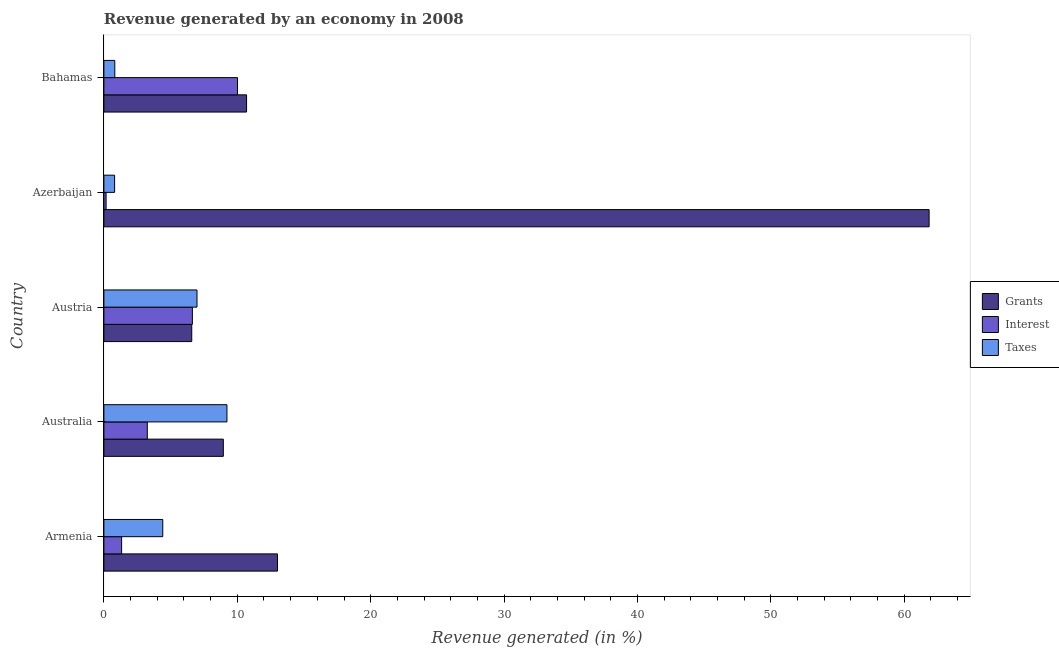How many groups of bars are there?
Ensure brevity in your answer.  5. Are the number of bars on each tick of the Y-axis equal?
Make the answer very short. Yes. How many bars are there on the 2nd tick from the top?
Make the answer very short. 3. In how many cases, is the number of bars for a given country not equal to the number of legend labels?
Make the answer very short. 0. What is the percentage of revenue generated by interest in Bahamas?
Offer a terse response. 10.02. Across all countries, what is the maximum percentage of revenue generated by grants?
Your answer should be very brief. 61.87. Across all countries, what is the minimum percentage of revenue generated by interest?
Ensure brevity in your answer.  0.17. In which country was the percentage of revenue generated by interest minimum?
Your response must be concise. Azerbaijan. What is the total percentage of revenue generated by grants in the graph?
Give a very brief answer. 101.12. What is the difference between the percentage of revenue generated by interest in Armenia and that in Azerbaijan?
Offer a very short reply. 1.17. What is the difference between the percentage of revenue generated by interest in Austria and the percentage of revenue generated by grants in Bahamas?
Make the answer very short. -4.06. What is the average percentage of revenue generated by taxes per country?
Provide a short and direct response. 4.45. What is the difference between the percentage of revenue generated by grants and percentage of revenue generated by interest in Armenia?
Provide a succinct answer. 11.69. In how many countries, is the percentage of revenue generated by taxes greater than 2 %?
Keep it short and to the point. 3. What is the ratio of the percentage of revenue generated by taxes in Armenia to that in Austria?
Your answer should be very brief. 0.63. Is the percentage of revenue generated by grants in Armenia less than that in Australia?
Keep it short and to the point. No. What is the difference between the highest and the second highest percentage of revenue generated by interest?
Ensure brevity in your answer.  3.38. What is the difference between the highest and the lowest percentage of revenue generated by interest?
Give a very brief answer. 9.85. Is the sum of the percentage of revenue generated by taxes in Armenia and Azerbaijan greater than the maximum percentage of revenue generated by grants across all countries?
Offer a terse response. No. What does the 3rd bar from the top in Bahamas represents?
Ensure brevity in your answer.  Grants. What does the 3rd bar from the bottom in Bahamas represents?
Keep it short and to the point. Taxes. Are all the bars in the graph horizontal?
Make the answer very short. Yes. Does the graph contain grids?
Keep it short and to the point. No. What is the title of the graph?
Make the answer very short. Revenue generated by an economy in 2008. Does "Czech Republic" appear as one of the legend labels in the graph?
Offer a very short reply. No. What is the label or title of the X-axis?
Ensure brevity in your answer.  Revenue generated (in %). What is the Revenue generated (in %) of Grants in Armenia?
Provide a succinct answer. 13.01. What is the Revenue generated (in %) of Interest in Armenia?
Provide a short and direct response. 1.33. What is the Revenue generated (in %) of Taxes in Armenia?
Your answer should be compact. 4.41. What is the Revenue generated (in %) of Grants in Australia?
Provide a short and direct response. 8.95. What is the Revenue generated (in %) in Interest in Australia?
Offer a terse response. 3.25. What is the Revenue generated (in %) in Taxes in Australia?
Ensure brevity in your answer.  9.23. What is the Revenue generated (in %) of Grants in Austria?
Your response must be concise. 6.59. What is the Revenue generated (in %) in Interest in Austria?
Your answer should be compact. 6.63. What is the Revenue generated (in %) in Taxes in Austria?
Ensure brevity in your answer.  6.98. What is the Revenue generated (in %) of Grants in Azerbaijan?
Make the answer very short. 61.87. What is the Revenue generated (in %) of Interest in Azerbaijan?
Make the answer very short. 0.17. What is the Revenue generated (in %) of Taxes in Azerbaijan?
Make the answer very short. 0.8. What is the Revenue generated (in %) of Grants in Bahamas?
Make the answer very short. 10.7. What is the Revenue generated (in %) of Interest in Bahamas?
Provide a short and direct response. 10.02. What is the Revenue generated (in %) in Taxes in Bahamas?
Provide a succinct answer. 0.82. Across all countries, what is the maximum Revenue generated (in %) in Grants?
Your answer should be compact. 61.87. Across all countries, what is the maximum Revenue generated (in %) of Interest?
Your response must be concise. 10.02. Across all countries, what is the maximum Revenue generated (in %) in Taxes?
Ensure brevity in your answer.  9.23. Across all countries, what is the minimum Revenue generated (in %) in Grants?
Offer a terse response. 6.59. Across all countries, what is the minimum Revenue generated (in %) of Interest?
Provide a succinct answer. 0.17. Across all countries, what is the minimum Revenue generated (in %) in Taxes?
Keep it short and to the point. 0.8. What is the total Revenue generated (in %) in Grants in the graph?
Your answer should be very brief. 101.12. What is the total Revenue generated (in %) in Interest in the graph?
Your answer should be compact. 21.4. What is the total Revenue generated (in %) in Taxes in the graph?
Make the answer very short. 22.24. What is the difference between the Revenue generated (in %) in Grants in Armenia and that in Australia?
Give a very brief answer. 4.06. What is the difference between the Revenue generated (in %) of Interest in Armenia and that in Australia?
Your answer should be compact. -1.92. What is the difference between the Revenue generated (in %) in Taxes in Armenia and that in Australia?
Your answer should be compact. -4.81. What is the difference between the Revenue generated (in %) of Grants in Armenia and that in Austria?
Offer a terse response. 6.43. What is the difference between the Revenue generated (in %) in Interest in Armenia and that in Austria?
Your answer should be compact. -5.3. What is the difference between the Revenue generated (in %) in Taxes in Armenia and that in Austria?
Provide a succinct answer. -2.57. What is the difference between the Revenue generated (in %) in Grants in Armenia and that in Azerbaijan?
Provide a short and direct response. -48.85. What is the difference between the Revenue generated (in %) in Interest in Armenia and that in Azerbaijan?
Your response must be concise. 1.16. What is the difference between the Revenue generated (in %) of Taxes in Armenia and that in Azerbaijan?
Your answer should be very brief. 3.61. What is the difference between the Revenue generated (in %) of Grants in Armenia and that in Bahamas?
Provide a succinct answer. 2.32. What is the difference between the Revenue generated (in %) in Interest in Armenia and that in Bahamas?
Make the answer very short. -8.69. What is the difference between the Revenue generated (in %) in Taxes in Armenia and that in Bahamas?
Provide a succinct answer. 3.6. What is the difference between the Revenue generated (in %) in Grants in Australia and that in Austria?
Your answer should be compact. 2.37. What is the difference between the Revenue generated (in %) of Interest in Australia and that in Austria?
Your response must be concise. -3.38. What is the difference between the Revenue generated (in %) in Taxes in Australia and that in Austria?
Your answer should be compact. 2.24. What is the difference between the Revenue generated (in %) of Grants in Australia and that in Azerbaijan?
Keep it short and to the point. -52.91. What is the difference between the Revenue generated (in %) in Interest in Australia and that in Azerbaijan?
Make the answer very short. 3.09. What is the difference between the Revenue generated (in %) in Taxes in Australia and that in Azerbaijan?
Offer a very short reply. 8.42. What is the difference between the Revenue generated (in %) of Grants in Australia and that in Bahamas?
Offer a terse response. -1.74. What is the difference between the Revenue generated (in %) in Interest in Australia and that in Bahamas?
Your response must be concise. -6.76. What is the difference between the Revenue generated (in %) of Taxes in Australia and that in Bahamas?
Keep it short and to the point. 8.41. What is the difference between the Revenue generated (in %) in Grants in Austria and that in Azerbaijan?
Provide a succinct answer. -55.28. What is the difference between the Revenue generated (in %) in Interest in Austria and that in Azerbaijan?
Provide a succinct answer. 6.47. What is the difference between the Revenue generated (in %) in Taxes in Austria and that in Azerbaijan?
Provide a succinct answer. 6.18. What is the difference between the Revenue generated (in %) of Grants in Austria and that in Bahamas?
Offer a very short reply. -4.11. What is the difference between the Revenue generated (in %) in Interest in Austria and that in Bahamas?
Ensure brevity in your answer.  -3.38. What is the difference between the Revenue generated (in %) in Taxes in Austria and that in Bahamas?
Ensure brevity in your answer.  6.16. What is the difference between the Revenue generated (in %) of Grants in Azerbaijan and that in Bahamas?
Your response must be concise. 51.17. What is the difference between the Revenue generated (in %) of Interest in Azerbaijan and that in Bahamas?
Offer a very short reply. -9.85. What is the difference between the Revenue generated (in %) of Taxes in Azerbaijan and that in Bahamas?
Make the answer very short. -0.01. What is the difference between the Revenue generated (in %) of Grants in Armenia and the Revenue generated (in %) of Interest in Australia?
Provide a short and direct response. 9.76. What is the difference between the Revenue generated (in %) in Grants in Armenia and the Revenue generated (in %) in Taxes in Australia?
Your response must be concise. 3.79. What is the difference between the Revenue generated (in %) of Interest in Armenia and the Revenue generated (in %) of Taxes in Australia?
Provide a short and direct response. -7.9. What is the difference between the Revenue generated (in %) in Grants in Armenia and the Revenue generated (in %) in Interest in Austria?
Keep it short and to the point. 6.38. What is the difference between the Revenue generated (in %) in Grants in Armenia and the Revenue generated (in %) in Taxes in Austria?
Your response must be concise. 6.03. What is the difference between the Revenue generated (in %) in Interest in Armenia and the Revenue generated (in %) in Taxes in Austria?
Make the answer very short. -5.65. What is the difference between the Revenue generated (in %) of Grants in Armenia and the Revenue generated (in %) of Interest in Azerbaijan?
Keep it short and to the point. 12.85. What is the difference between the Revenue generated (in %) of Grants in Armenia and the Revenue generated (in %) of Taxes in Azerbaijan?
Keep it short and to the point. 12.21. What is the difference between the Revenue generated (in %) of Interest in Armenia and the Revenue generated (in %) of Taxes in Azerbaijan?
Provide a succinct answer. 0.53. What is the difference between the Revenue generated (in %) in Grants in Armenia and the Revenue generated (in %) in Interest in Bahamas?
Offer a terse response. 3. What is the difference between the Revenue generated (in %) of Grants in Armenia and the Revenue generated (in %) of Taxes in Bahamas?
Your response must be concise. 12.2. What is the difference between the Revenue generated (in %) in Interest in Armenia and the Revenue generated (in %) in Taxes in Bahamas?
Provide a short and direct response. 0.51. What is the difference between the Revenue generated (in %) in Grants in Australia and the Revenue generated (in %) in Interest in Austria?
Offer a very short reply. 2.32. What is the difference between the Revenue generated (in %) in Grants in Australia and the Revenue generated (in %) in Taxes in Austria?
Ensure brevity in your answer.  1.97. What is the difference between the Revenue generated (in %) of Interest in Australia and the Revenue generated (in %) of Taxes in Austria?
Offer a very short reply. -3.73. What is the difference between the Revenue generated (in %) in Grants in Australia and the Revenue generated (in %) in Interest in Azerbaijan?
Give a very brief answer. 8.79. What is the difference between the Revenue generated (in %) of Grants in Australia and the Revenue generated (in %) of Taxes in Azerbaijan?
Offer a terse response. 8.15. What is the difference between the Revenue generated (in %) in Interest in Australia and the Revenue generated (in %) in Taxes in Azerbaijan?
Ensure brevity in your answer.  2.45. What is the difference between the Revenue generated (in %) in Grants in Australia and the Revenue generated (in %) in Interest in Bahamas?
Your answer should be compact. -1.06. What is the difference between the Revenue generated (in %) of Grants in Australia and the Revenue generated (in %) of Taxes in Bahamas?
Keep it short and to the point. 8.14. What is the difference between the Revenue generated (in %) in Interest in Australia and the Revenue generated (in %) in Taxes in Bahamas?
Keep it short and to the point. 2.44. What is the difference between the Revenue generated (in %) of Grants in Austria and the Revenue generated (in %) of Interest in Azerbaijan?
Your response must be concise. 6.42. What is the difference between the Revenue generated (in %) in Grants in Austria and the Revenue generated (in %) in Taxes in Azerbaijan?
Your answer should be compact. 5.78. What is the difference between the Revenue generated (in %) in Interest in Austria and the Revenue generated (in %) in Taxes in Azerbaijan?
Keep it short and to the point. 5.83. What is the difference between the Revenue generated (in %) in Grants in Austria and the Revenue generated (in %) in Interest in Bahamas?
Give a very brief answer. -3.43. What is the difference between the Revenue generated (in %) in Grants in Austria and the Revenue generated (in %) in Taxes in Bahamas?
Offer a terse response. 5.77. What is the difference between the Revenue generated (in %) of Interest in Austria and the Revenue generated (in %) of Taxes in Bahamas?
Give a very brief answer. 5.82. What is the difference between the Revenue generated (in %) of Grants in Azerbaijan and the Revenue generated (in %) of Interest in Bahamas?
Your response must be concise. 51.85. What is the difference between the Revenue generated (in %) in Grants in Azerbaijan and the Revenue generated (in %) in Taxes in Bahamas?
Make the answer very short. 61.05. What is the difference between the Revenue generated (in %) in Interest in Azerbaijan and the Revenue generated (in %) in Taxes in Bahamas?
Your answer should be compact. -0.65. What is the average Revenue generated (in %) in Grants per country?
Give a very brief answer. 20.22. What is the average Revenue generated (in %) in Interest per country?
Offer a terse response. 4.28. What is the average Revenue generated (in %) of Taxes per country?
Provide a short and direct response. 4.45. What is the difference between the Revenue generated (in %) in Grants and Revenue generated (in %) in Interest in Armenia?
Your answer should be very brief. 11.68. What is the difference between the Revenue generated (in %) of Grants and Revenue generated (in %) of Taxes in Armenia?
Your answer should be compact. 8.6. What is the difference between the Revenue generated (in %) of Interest and Revenue generated (in %) of Taxes in Armenia?
Provide a succinct answer. -3.08. What is the difference between the Revenue generated (in %) in Grants and Revenue generated (in %) in Interest in Australia?
Your answer should be very brief. 5.7. What is the difference between the Revenue generated (in %) of Grants and Revenue generated (in %) of Taxes in Australia?
Provide a short and direct response. -0.27. What is the difference between the Revenue generated (in %) in Interest and Revenue generated (in %) in Taxes in Australia?
Offer a very short reply. -5.97. What is the difference between the Revenue generated (in %) of Grants and Revenue generated (in %) of Interest in Austria?
Make the answer very short. -0.05. What is the difference between the Revenue generated (in %) of Grants and Revenue generated (in %) of Taxes in Austria?
Offer a terse response. -0.39. What is the difference between the Revenue generated (in %) in Interest and Revenue generated (in %) in Taxes in Austria?
Ensure brevity in your answer.  -0.35. What is the difference between the Revenue generated (in %) in Grants and Revenue generated (in %) in Interest in Azerbaijan?
Make the answer very short. 61.7. What is the difference between the Revenue generated (in %) in Grants and Revenue generated (in %) in Taxes in Azerbaijan?
Ensure brevity in your answer.  61.06. What is the difference between the Revenue generated (in %) in Interest and Revenue generated (in %) in Taxes in Azerbaijan?
Ensure brevity in your answer.  -0.64. What is the difference between the Revenue generated (in %) of Grants and Revenue generated (in %) of Interest in Bahamas?
Your answer should be compact. 0.68. What is the difference between the Revenue generated (in %) of Grants and Revenue generated (in %) of Taxes in Bahamas?
Your answer should be compact. 9.88. What is the difference between the Revenue generated (in %) of Interest and Revenue generated (in %) of Taxes in Bahamas?
Give a very brief answer. 9.2. What is the ratio of the Revenue generated (in %) in Grants in Armenia to that in Australia?
Provide a short and direct response. 1.45. What is the ratio of the Revenue generated (in %) of Interest in Armenia to that in Australia?
Your answer should be very brief. 0.41. What is the ratio of the Revenue generated (in %) of Taxes in Armenia to that in Australia?
Provide a succinct answer. 0.48. What is the ratio of the Revenue generated (in %) of Grants in Armenia to that in Austria?
Offer a very short reply. 1.98. What is the ratio of the Revenue generated (in %) of Interest in Armenia to that in Austria?
Your response must be concise. 0.2. What is the ratio of the Revenue generated (in %) of Taxes in Armenia to that in Austria?
Make the answer very short. 0.63. What is the ratio of the Revenue generated (in %) of Grants in Armenia to that in Azerbaijan?
Make the answer very short. 0.21. What is the ratio of the Revenue generated (in %) in Interest in Armenia to that in Azerbaijan?
Provide a succinct answer. 8.05. What is the ratio of the Revenue generated (in %) in Taxes in Armenia to that in Azerbaijan?
Offer a very short reply. 5.49. What is the ratio of the Revenue generated (in %) in Grants in Armenia to that in Bahamas?
Keep it short and to the point. 1.22. What is the ratio of the Revenue generated (in %) in Interest in Armenia to that in Bahamas?
Offer a very short reply. 0.13. What is the ratio of the Revenue generated (in %) in Taxes in Armenia to that in Bahamas?
Give a very brief answer. 5.4. What is the ratio of the Revenue generated (in %) of Grants in Australia to that in Austria?
Offer a very short reply. 1.36. What is the ratio of the Revenue generated (in %) of Interest in Australia to that in Austria?
Keep it short and to the point. 0.49. What is the ratio of the Revenue generated (in %) of Taxes in Australia to that in Austria?
Keep it short and to the point. 1.32. What is the ratio of the Revenue generated (in %) of Grants in Australia to that in Azerbaijan?
Offer a terse response. 0.14. What is the ratio of the Revenue generated (in %) in Interest in Australia to that in Azerbaijan?
Give a very brief answer. 19.69. What is the ratio of the Revenue generated (in %) in Taxes in Australia to that in Azerbaijan?
Provide a succinct answer. 11.47. What is the ratio of the Revenue generated (in %) in Grants in Australia to that in Bahamas?
Your response must be concise. 0.84. What is the ratio of the Revenue generated (in %) in Interest in Australia to that in Bahamas?
Make the answer very short. 0.32. What is the ratio of the Revenue generated (in %) in Taxes in Australia to that in Bahamas?
Give a very brief answer. 11.28. What is the ratio of the Revenue generated (in %) of Grants in Austria to that in Azerbaijan?
Offer a very short reply. 0.11. What is the ratio of the Revenue generated (in %) in Interest in Austria to that in Azerbaijan?
Your response must be concise. 40.15. What is the ratio of the Revenue generated (in %) of Taxes in Austria to that in Azerbaijan?
Provide a short and direct response. 8.68. What is the ratio of the Revenue generated (in %) of Grants in Austria to that in Bahamas?
Make the answer very short. 0.62. What is the ratio of the Revenue generated (in %) in Interest in Austria to that in Bahamas?
Make the answer very short. 0.66. What is the ratio of the Revenue generated (in %) in Taxes in Austria to that in Bahamas?
Give a very brief answer. 8.54. What is the ratio of the Revenue generated (in %) in Grants in Azerbaijan to that in Bahamas?
Provide a succinct answer. 5.78. What is the ratio of the Revenue generated (in %) of Interest in Azerbaijan to that in Bahamas?
Ensure brevity in your answer.  0.02. What is the ratio of the Revenue generated (in %) of Taxes in Azerbaijan to that in Bahamas?
Provide a succinct answer. 0.98. What is the difference between the highest and the second highest Revenue generated (in %) of Grants?
Give a very brief answer. 48.85. What is the difference between the highest and the second highest Revenue generated (in %) in Interest?
Make the answer very short. 3.38. What is the difference between the highest and the second highest Revenue generated (in %) of Taxes?
Make the answer very short. 2.24. What is the difference between the highest and the lowest Revenue generated (in %) of Grants?
Offer a very short reply. 55.28. What is the difference between the highest and the lowest Revenue generated (in %) in Interest?
Provide a succinct answer. 9.85. What is the difference between the highest and the lowest Revenue generated (in %) in Taxes?
Give a very brief answer. 8.42. 